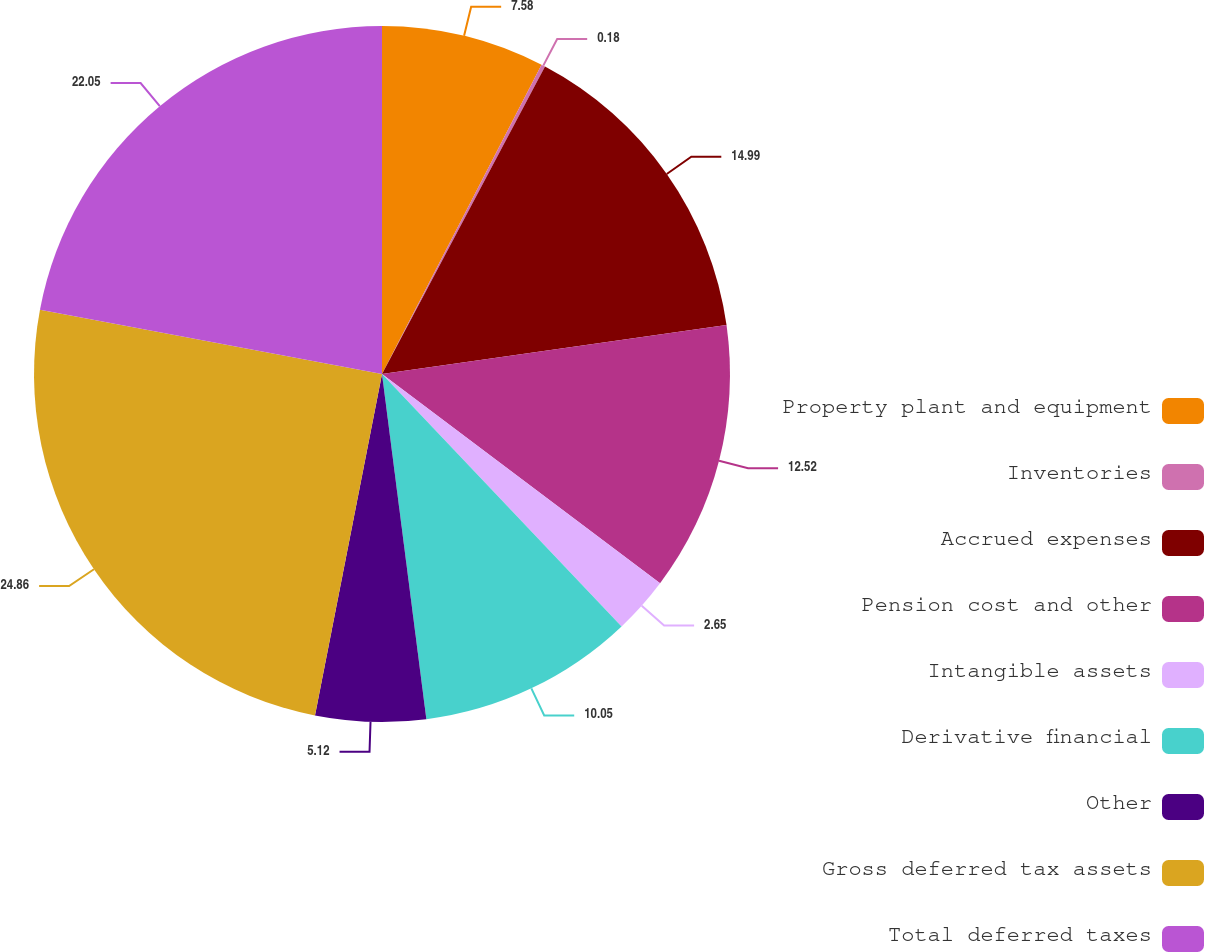Convert chart to OTSL. <chart><loc_0><loc_0><loc_500><loc_500><pie_chart><fcel>Property plant and equipment<fcel>Inventories<fcel>Accrued expenses<fcel>Pension cost and other<fcel>Intangible assets<fcel>Derivative financial<fcel>Other<fcel>Gross deferred tax assets<fcel>Total deferred taxes<nl><fcel>7.58%<fcel>0.18%<fcel>14.99%<fcel>12.52%<fcel>2.65%<fcel>10.05%<fcel>5.12%<fcel>24.87%<fcel>22.05%<nl></chart> 